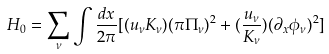Convert formula to latex. <formula><loc_0><loc_0><loc_500><loc_500>H _ { 0 } = \sum _ { \nu } \int \frac { d x } { 2 \pi } [ ( u _ { \nu } K _ { \nu } ) ( \pi \Pi _ { \nu } ) ^ { 2 } + ( \frac { u _ { \nu } } { K _ { \nu } } ) ( \partial _ { x } \phi _ { \nu } ) ^ { 2 } ]</formula> 